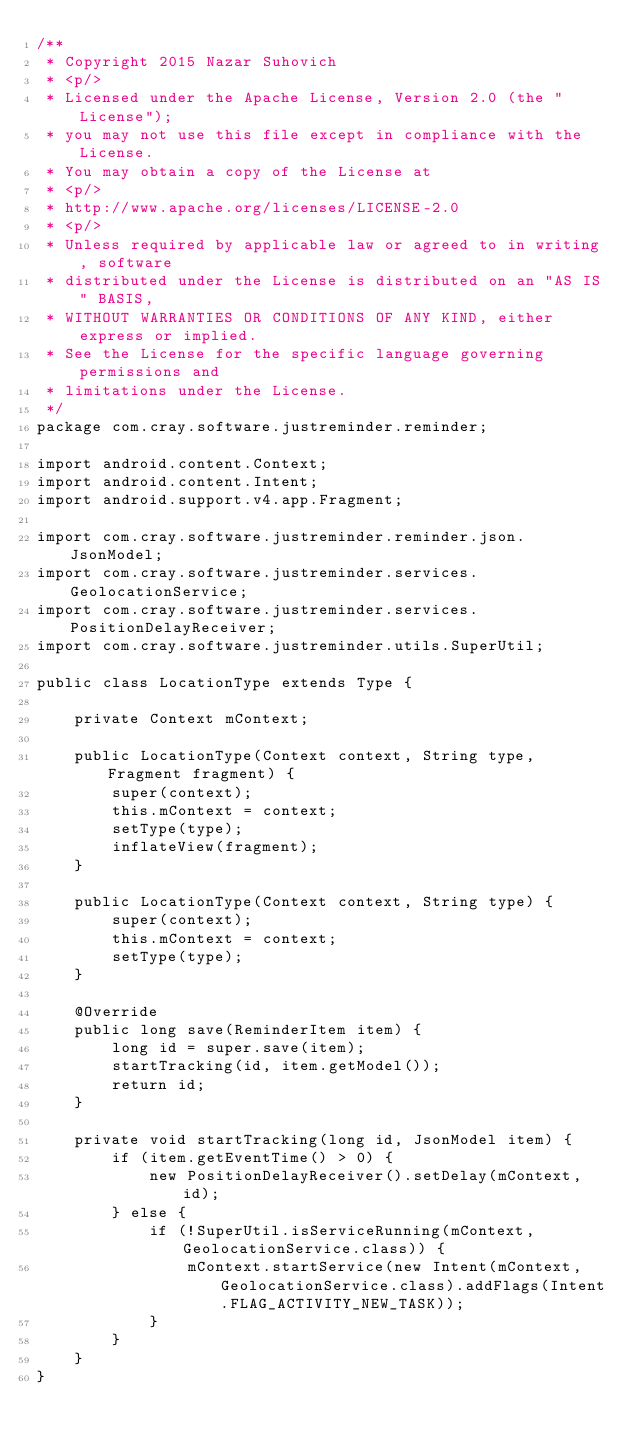<code> <loc_0><loc_0><loc_500><loc_500><_Java_>/**
 * Copyright 2015 Nazar Suhovich
 * <p/>
 * Licensed under the Apache License, Version 2.0 (the "License");
 * you may not use this file except in compliance with the License.
 * You may obtain a copy of the License at
 * <p/>
 * http://www.apache.org/licenses/LICENSE-2.0
 * <p/>
 * Unless required by applicable law or agreed to in writing, software
 * distributed under the License is distributed on an "AS IS" BASIS,
 * WITHOUT WARRANTIES OR CONDITIONS OF ANY KIND, either express or implied.
 * See the License for the specific language governing permissions and
 * limitations under the License.
 */
package com.cray.software.justreminder.reminder;

import android.content.Context;
import android.content.Intent;
import android.support.v4.app.Fragment;

import com.cray.software.justreminder.reminder.json.JsonModel;
import com.cray.software.justreminder.services.GeolocationService;
import com.cray.software.justreminder.services.PositionDelayReceiver;
import com.cray.software.justreminder.utils.SuperUtil;

public class LocationType extends Type {

    private Context mContext;

    public LocationType(Context context, String type, Fragment fragment) {
        super(context);
        this.mContext = context;
        setType(type);
        inflateView(fragment);
    }

    public LocationType(Context context, String type) {
        super(context);
        this.mContext = context;
        setType(type);
    }

    @Override
    public long save(ReminderItem item) {
        long id = super.save(item);
        startTracking(id, item.getModel());
        return id;
    }

    private void startTracking(long id, JsonModel item) {
        if (item.getEventTime() > 0) {
            new PositionDelayReceiver().setDelay(mContext, id);
        } else {
            if (!SuperUtil.isServiceRunning(mContext, GeolocationService.class)) {
                mContext.startService(new Intent(mContext, GeolocationService.class).addFlags(Intent.FLAG_ACTIVITY_NEW_TASK));
            }
        }
    }
}
</code> 